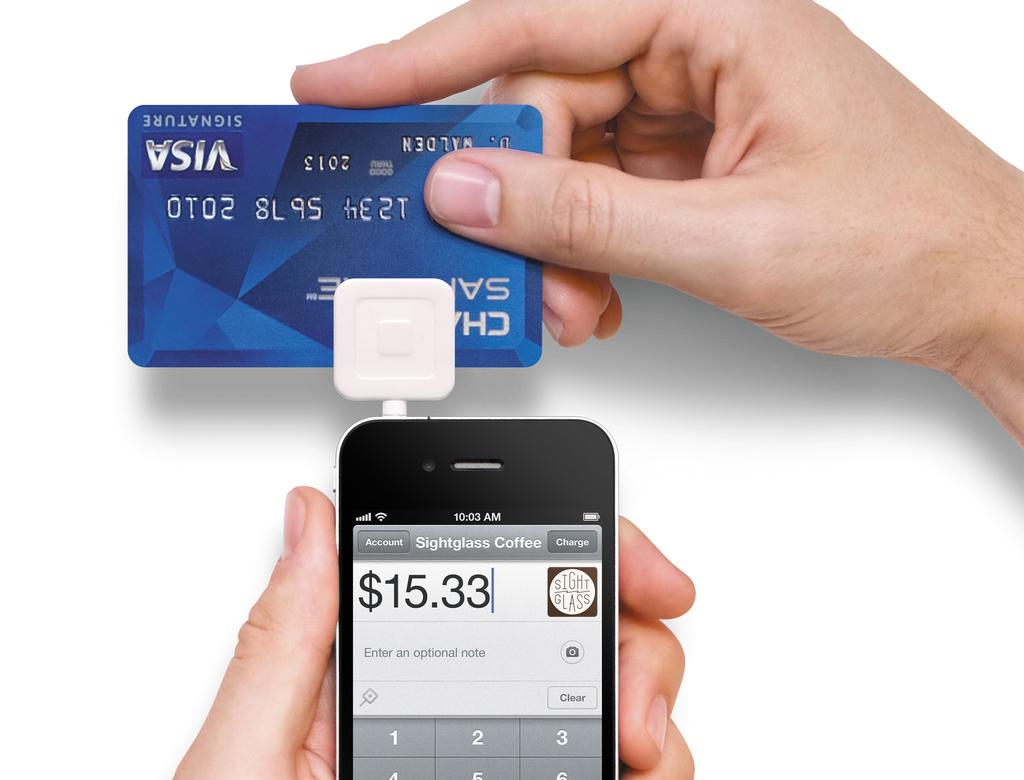What object is being held by a human hand in the image? The mobile is being held by a human hand in the image. What is the main subject of the image? The main subject of the image is the mobile. What can be seen in the middle of the image? There is a debit card in the middle of the image. What is the color of the background in the image? The background of the image is white. How many people are visible in the image? There are no people visible in the image; only a mobile, a debit card, and a human hand holding the mobile are present. 